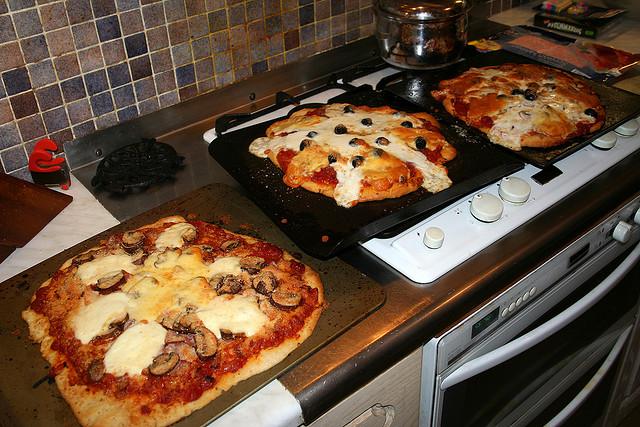What toppings are on the pizzas?
Answer briefly. Mushrooms and olives. How many pizzas are on the stove?
Give a very brief answer. 2. This contain  cheese?
Quick response, please. Yes. Are there mushrooms?
Short answer required. Yes. 